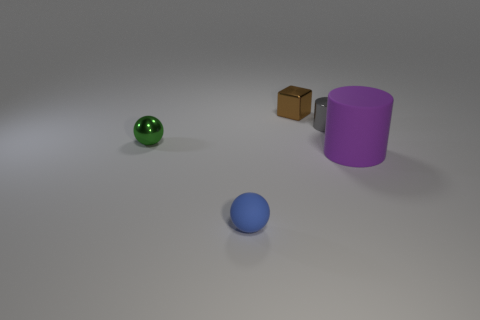Add 2 tiny brown shiny cubes. How many objects exist? 7 Subtract all blocks. How many objects are left? 4 Add 1 blocks. How many blocks exist? 2 Subtract 0 cyan cylinders. How many objects are left? 5 Subtract all small green metallic objects. Subtract all shiny objects. How many objects are left? 1 Add 3 small rubber balls. How many small rubber balls are left? 4 